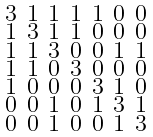<formula> <loc_0><loc_0><loc_500><loc_500>\begin{smallmatrix} 3 & 1 & 1 & 1 & 1 & 0 & 0 \\ 1 & 3 & 1 & 1 & 0 & 0 & 0 \\ 1 & 1 & 3 & 0 & 0 & 1 & 1 \\ 1 & 1 & 0 & 3 & 0 & 0 & 0 \\ 1 & 0 & 0 & 0 & 3 & 1 & 0 \\ 0 & 0 & 1 & 0 & 1 & 3 & 1 \\ 0 & 0 & 1 & 0 & 0 & 1 & 3 \end{smallmatrix}</formula> 